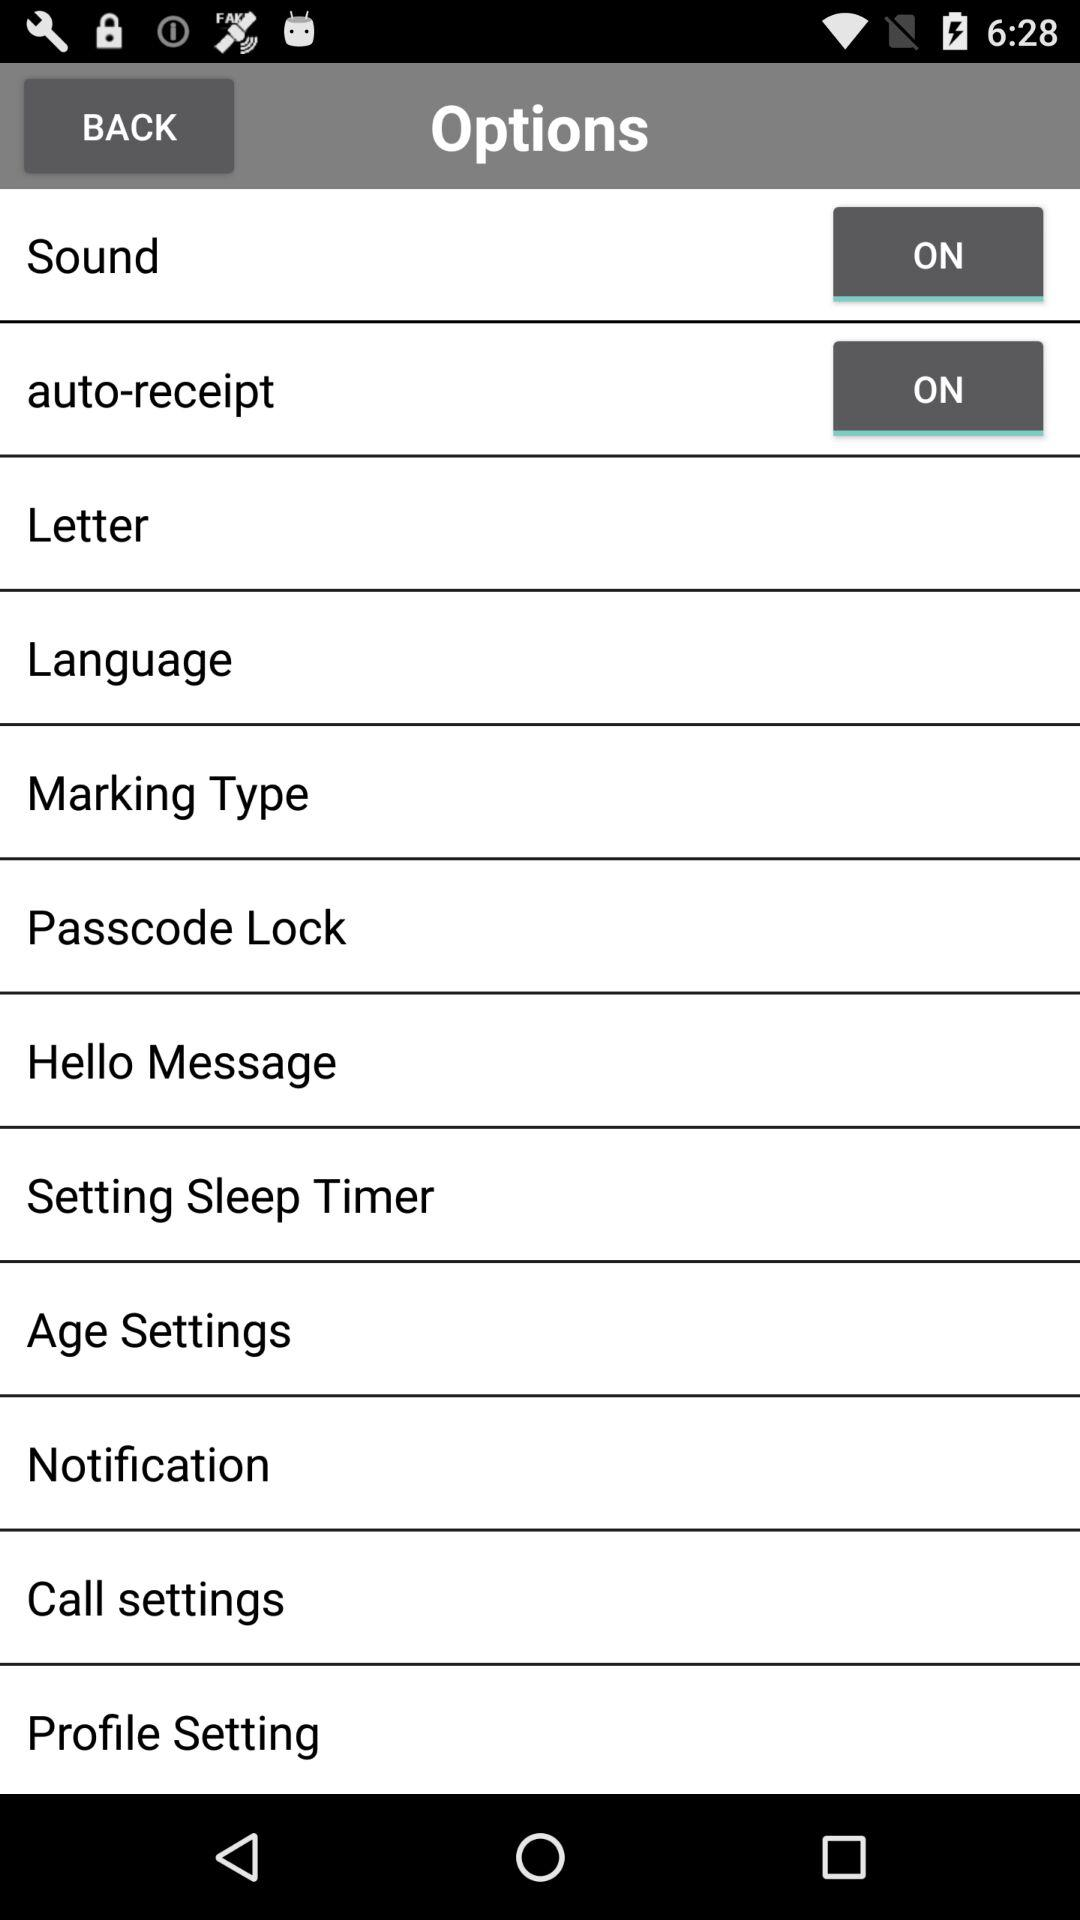What is the status of "auto-receipt" setting? The status is "on". 